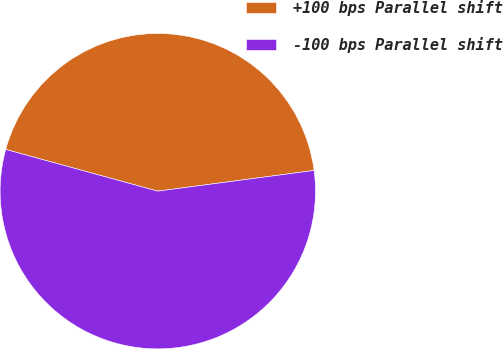Convert chart. <chart><loc_0><loc_0><loc_500><loc_500><pie_chart><fcel>+100 bps Parallel shift<fcel>-100 bps Parallel shift<nl><fcel>43.64%<fcel>56.36%<nl></chart> 